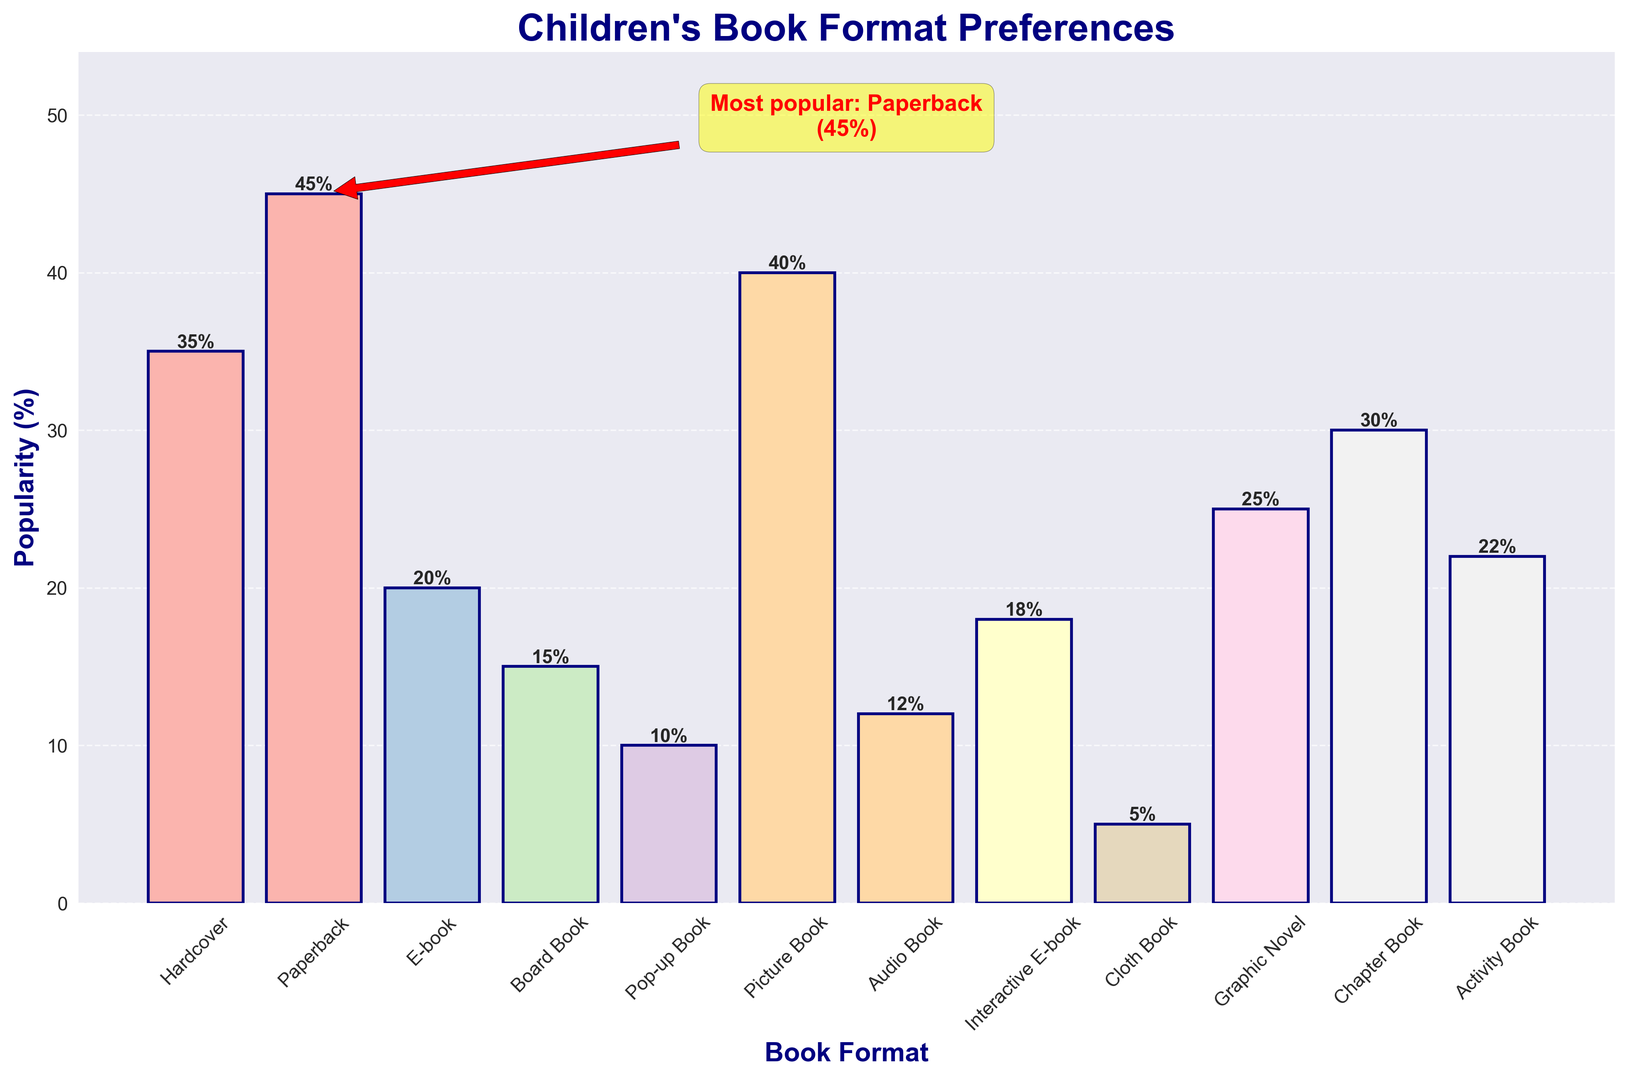Which book format is the most popular among children? The figure shows a bar chart illustrating the popularity of various book formats. The text annotation highlights that Paperback is the most popular format with 45% popularity.
Answer: Paperback What is the difference in popularity between Hardcover and E-book formats? To find the difference, look at the bar heights for Hardcover and E-book. Hardcover is at 35%, and E-book is at 20%. Subtract 20 from 35 to get the difference.
Answer: 15% Which format is more popular: Picture Book or Graphic Novel? By comparing the heights of the bars, Picture Book has a popularity of 40% while Graphic Novel has a popularity of 25%.
Answer: Picture Book How much more popular is Paperback compared to the least popular format? Identify the least popular format, which is Cloth Book at 5%. Paperback has 45% popularity, so the difference is 45 - 5 = 40%.
Answer: 40% What is the total popularity percentage of Picture Book, Pop-up Book, and Board Book formats? Sum the individual percentage values: Picture Book (40%) + Pop-up Book (10%) + Board Book (15%) = 65%.
Answer: 65% Which book format has the lowest popularity? The bar chart shows that Cloth Book has the lowest popularity, with a value of 5%.
Answer: Cloth Book Which three book formats are closest in popularity? Board Book (15%), Audio Book (12%), and Interactive E-book (18%) are closely ranked. Check the minor differences in their percentages.
Answer: Board Book, Audio Book, Interactive E-book How many book formats have a popularity above 30%? Check the figure and count formats exceeding 30%: Hardcover (35%), Paperback (45%), Picture Book (40%), and Chapter Book (30%). Thus, four formats are equal or above 30%.
Answer: 4 What's the average popularity of all book formats shown? Add the popularity values and divide by the number of formats: (35 + 45 + 20 + 15 + 10 + 40 + 12 + 18 + 5 + 25 + 30 + 22) / 12 = 23.8%
Answer: 23.8% Which formats are ranked higher than Audio Book in terms of popularity? Identify formats with popularity greater than Audio Book's 12%: Hardcover (35%), Paperback (45%), E-book (20%), Board Book (15%), Pop-up Book (10%), Picture Book (40%), Interactive E-book (18%), Graphic Novel (25%), Chapter Book (30%), and Activity Book (22%). Note that Pop-up Book is ranked lower than Audio Book.
Answer: 9 formats 